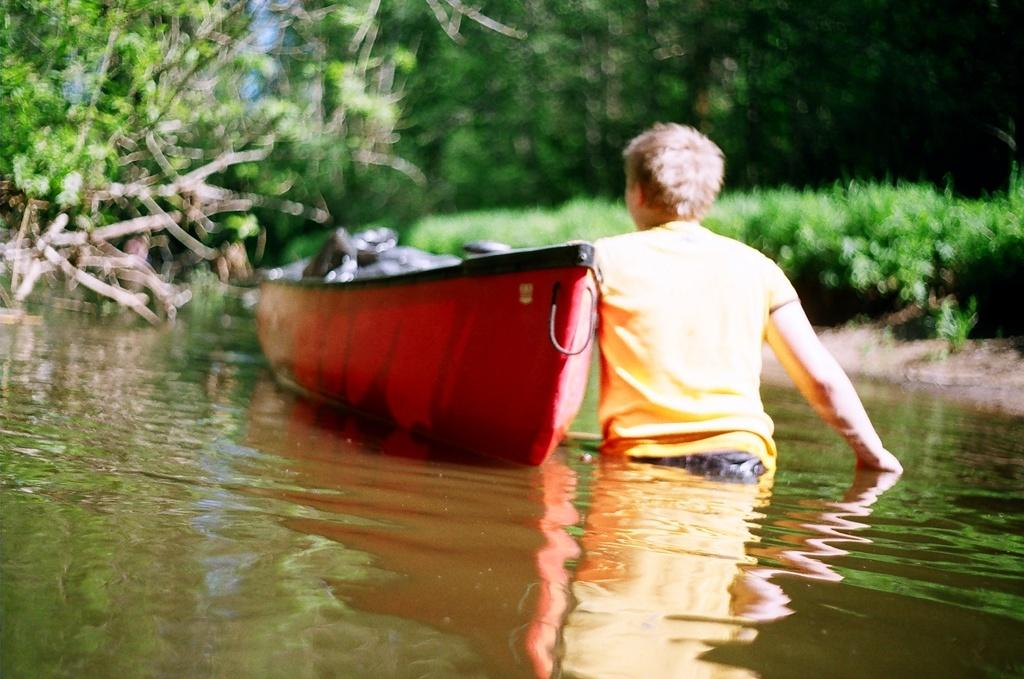What body of water is present at the bottom of the image? There is a river at the bottom of the image. What is in the river? There is a boat in the river. Who is in the boat? There is a person in the boat. What can be seen in the background of the image? There are trees and plants in the background of the image. What type of meat is being cooked on the bell in the image? There is no meat or bell present in the image. What type of cushion is being used by the person in the boat? There is no cushion visible in the image; the person is simply sitting in the boat. 